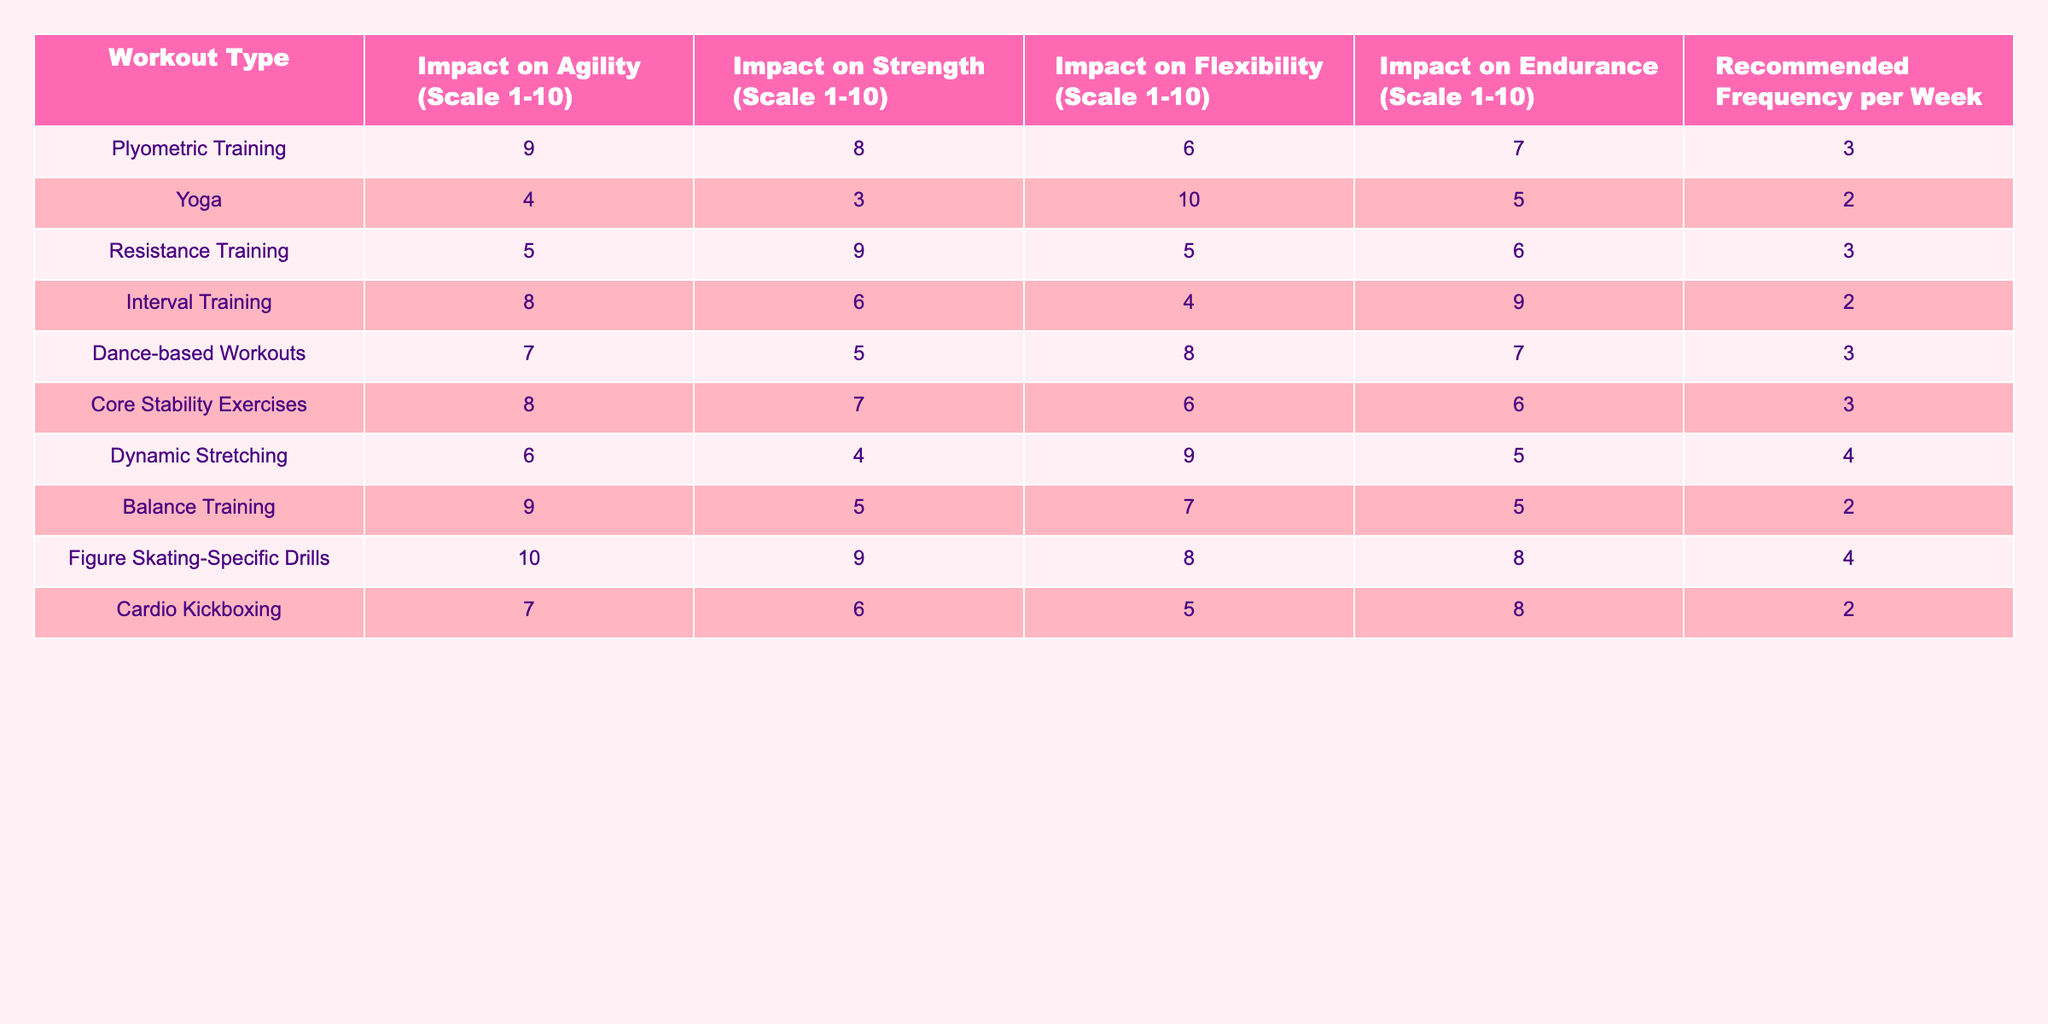What is the impact on agility from Dance-based Workouts? The table indicates the impact on agility for Dance-based Workouts is 7 on a scale of 1 to 10.
Answer: 7 Which workout type has the highest impact on flexibility? By comparing the flexibility scores, Yoga has the highest impact with a score of 10.
Answer: Yoga What is the average impact on strength for Plyometric Training and Resistance Training? The strength scores for Plyometric Training and Resistance Training are 8 and 9 respectively. To find the average, we sum these scores (8 + 9 = 17) and divide by 2, giving us 17 / 2 = 8.5.
Answer: 8.5 Is the impact on endurance for Figure Skating-Specific Drills greater than that for Interval Training? The impact on endurance for Figure Skating-Specific Drills is 8, while for Interval Training it is 9. Since 8 is less than 9, the statement is false.
Answer: No Which workout types have a recommended frequency of 3 times per week, and what is their average impact on agility? The workout types with a recommended frequency of 3 times per week are Plyometric Training, Resistance Training, Dance-based Workouts, and Core Stability Exercises with agility scores of 9, 5, 7, and 8 respectively. To find the average agility impact, we sum these scores (9 + 5 + 7 + 8 = 29) and divide by 4 to get 29 / 4 = 7.25.
Answer: 7.25 